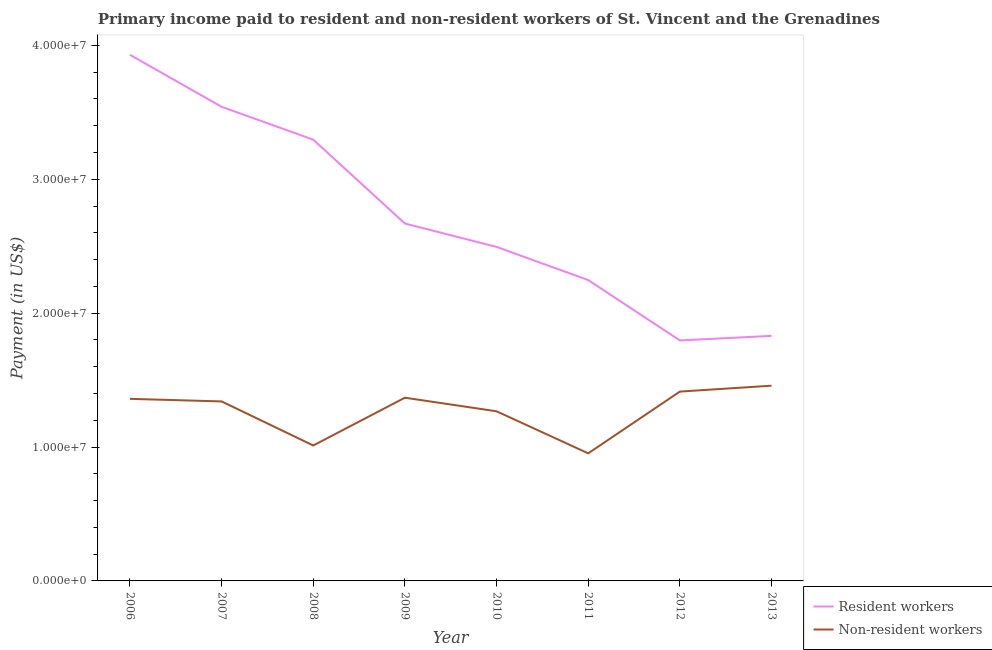What is the payment made to non-resident workers in 2013?
Offer a terse response. 1.46e+07. Across all years, what is the maximum payment made to non-resident workers?
Provide a succinct answer. 1.46e+07. Across all years, what is the minimum payment made to non-resident workers?
Ensure brevity in your answer.  9.53e+06. In which year was the payment made to non-resident workers maximum?
Give a very brief answer. 2013. What is the total payment made to resident workers in the graph?
Make the answer very short. 2.18e+08. What is the difference between the payment made to resident workers in 2007 and that in 2011?
Provide a short and direct response. 1.29e+07. What is the difference between the payment made to resident workers in 2010 and the payment made to non-resident workers in 2011?
Provide a succinct answer. 1.54e+07. What is the average payment made to non-resident workers per year?
Offer a terse response. 1.27e+07. In the year 2008, what is the difference between the payment made to non-resident workers and payment made to resident workers?
Make the answer very short. -2.28e+07. In how many years, is the payment made to resident workers greater than 38000000 US$?
Offer a very short reply. 1. What is the ratio of the payment made to resident workers in 2006 to that in 2009?
Ensure brevity in your answer.  1.47. Is the difference between the payment made to non-resident workers in 2008 and 2009 greater than the difference between the payment made to resident workers in 2008 and 2009?
Provide a short and direct response. No. What is the difference between the highest and the second highest payment made to resident workers?
Ensure brevity in your answer.  3.88e+06. What is the difference between the highest and the lowest payment made to resident workers?
Your answer should be very brief. 2.13e+07. In how many years, is the payment made to non-resident workers greater than the average payment made to non-resident workers taken over all years?
Your answer should be very brief. 5. Does the payment made to non-resident workers monotonically increase over the years?
Provide a short and direct response. No. Is the payment made to non-resident workers strictly greater than the payment made to resident workers over the years?
Keep it short and to the point. No. How many lines are there?
Your response must be concise. 2. What is the difference between two consecutive major ticks on the Y-axis?
Give a very brief answer. 1.00e+07. Are the values on the major ticks of Y-axis written in scientific E-notation?
Your response must be concise. Yes. Does the graph contain any zero values?
Ensure brevity in your answer.  No. Does the graph contain grids?
Make the answer very short. No. Where does the legend appear in the graph?
Your response must be concise. Bottom right. How many legend labels are there?
Ensure brevity in your answer.  2. How are the legend labels stacked?
Offer a terse response. Vertical. What is the title of the graph?
Give a very brief answer. Primary income paid to resident and non-resident workers of St. Vincent and the Grenadines. Does "Urban" appear as one of the legend labels in the graph?
Ensure brevity in your answer.  No. What is the label or title of the X-axis?
Offer a very short reply. Year. What is the label or title of the Y-axis?
Your answer should be very brief. Payment (in US$). What is the Payment (in US$) in Resident workers in 2006?
Provide a succinct answer. 3.93e+07. What is the Payment (in US$) in Non-resident workers in 2006?
Your answer should be compact. 1.36e+07. What is the Payment (in US$) of Resident workers in 2007?
Give a very brief answer. 3.54e+07. What is the Payment (in US$) of Non-resident workers in 2007?
Your response must be concise. 1.34e+07. What is the Payment (in US$) in Resident workers in 2008?
Your response must be concise. 3.30e+07. What is the Payment (in US$) in Non-resident workers in 2008?
Your response must be concise. 1.01e+07. What is the Payment (in US$) of Resident workers in 2009?
Your response must be concise. 2.67e+07. What is the Payment (in US$) in Non-resident workers in 2009?
Keep it short and to the point. 1.37e+07. What is the Payment (in US$) of Resident workers in 2010?
Make the answer very short. 2.49e+07. What is the Payment (in US$) of Non-resident workers in 2010?
Provide a succinct answer. 1.27e+07. What is the Payment (in US$) of Resident workers in 2011?
Provide a short and direct response. 2.25e+07. What is the Payment (in US$) in Non-resident workers in 2011?
Your answer should be compact. 9.53e+06. What is the Payment (in US$) of Resident workers in 2012?
Ensure brevity in your answer.  1.80e+07. What is the Payment (in US$) in Non-resident workers in 2012?
Make the answer very short. 1.41e+07. What is the Payment (in US$) in Resident workers in 2013?
Offer a very short reply. 1.83e+07. What is the Payment (in US$) of Non-resident workers in 2013?
Offer a very short reply. 1.46e+07. Across all years, what is the maximum Payment (in US$) of Resident workers?
Offer a terse response. 3.93e+07. Across all years, what is the maximum Payment (in US$) of Non-resident workers?
Make the answer very short. 1.46e+07. Across all years, what is the minimum Payment (in US$) of Resident workers?
Your answer should be very brief. 1.80e+07. Across all years, what is the minimum Payment (in US$) of Non-resident workers?
Your answer should be very brief. 9.53e+06. What is the total Payment (in US$) in Resident workers in the graph?
Your answer should be compact. 2.18e+08. What is the total Payment (in US$) in Non-resident workers in the graph?
Ensure brevity in your answer.  1.02e+08. What is the difference between the Payment (in US$) in Resident workers in 2006 and that in 2007?
Make the answer very short. 3.88e+06. What is the difference between the Payment (in US$) of Non-resident workers in 2006 and that in 2007?
Offer a terse response. 1.92e+05. What is the difference between the Payment (in US$) of Resident workers in 2006 and that in 2008?
Your answer should be compact. 6.34e+06. What is the difference between the Payment (in US$) of Non-resident workers in 2006 and that in 2008?
Offer a very short reply. 3.48e+06. What is the difference between the Payment (in US$) of Resident workers in 2006 and that in 2009?
Offer a terse response. 1.26e+07. What is the difference between the Payment (in US$) in Non-resident workers in 2006 and that in 2009?
Your answer should be very brief. -8.47e+04. What is the difference between the Payment (in US$) of Resident workers in 2006 and that in 2010?
Your response must be concise. 1.43e+07. What is the difference between the Payment (in US$) of Non-resident workers in 2006 and that in 2010?
Provide a succinct answer. 9.29e+05. What is the difference between the Payment (in US$) of Resident workers in 2006 and that in 2011?
Offer a terse response. 1.68e+07. What is the difference between the Payment (in US$) of Non-resident workers in 2006 and that in 2011?
Make the answer very short. 4.07e+06. What is the difference between the Payment (in US$) in Resident workers in 2006 and that in 2012?
Make the answer very short. 2.13e+07. What is the difference between the Payment (in US$) in Non-resident workers in 2006 and that in 2012?
Give a very brief answer. -5.43e+05. What is the difference between the Payment (in US$) in Resident workers in 2006 and that in 2013?
Provide a succinct answer. 2.10e+07. What is the difference between the Payment (in US$) in Non-resident workers in 2006 and that in 2013?
Make the answer very short. -9.82e+05. What is the difference between the Payment (in US$) of Resident workers in 2007 and that in 2008?
Your answer should be compact. 2.46e+06. What is the difference between the Payment (in US$) of Non-resident workers in 2007 and that in 2008?
Offer a very short reply. 3.29e+06. What is the difference between the Payment (in US$) in Resident workers in 2007 and that in 2009?
Ensure brevity in your answer.  8.72e+06. What is the difference between the Payment (in US$) of Non-resident workers in 2007 and that in 2009?
Provide a short and direct response. -2.77e+05. What is the difference between the Payment (in US$) in Resident workers in 2007 and that in 2010?
Your response must be concise. 1.05e+07. What is the difference between the Payment (in US$) of Non-resident workers in 2007 and that in 2010?
Give a very brief answer. 7.36e+05. What is the difference between the Payment (in US$) in Resident workers in 2007 and that in 2011?
Provide a succinct answer. 1.29e+07. What is the difference between the Payment (in US$) of Non-resident workers in 2007 and that in 2011?
Your response must be concise. 3.88e+06. What is the difference between the Payment (in US$) of Resident workers in 2007 and that in 2012?
Your answer should be very brief. 1.75e+07. What is the difference between the Payment (in US$) of Non-resident workers in 2007 and that in 2012?
Keep it short and to the point. -7.35e+05. What is the difference between the Payment (in US$) in Resident workers in 2007 and that in 2013?
Provide a succinct answer. 1.71e+07. What is the difference between the Payment (in US$) of Non-resident workers in 2007 and that in 2013?
Keep it short and to the point. -1.17e+06. What is the difference between the Payment (in US$) of Resident workers in 2008 and that in 2009?
Provide a succinct answer. 6.26e+06. What is the difference between the Payment (in US$) in Non-resident workers in 2008 and that in 2009?
Provide a succinct answer. -3.57e+06. What is the difference between the Payment (in US$) in Resident workers in 2008 and that in 2010?
Your answer should be compact. 8.01e+06. What is the difference between the Payment (in US$) of Non-resident workers in 2008 and that in 2010?
Your answer should be very brief. -2.55e+06. What is the difference between the Payment (in US$) of Resident workers in 2008 and that in 2011?
Provide a short and direct response. 1.05e+07. What is the difference between the Payment (in US$) in Non-resident workers in 2008 and that in 2011?
Keep it short and to the point. 5.87e+05. What is the difference between the Payment (in US$) of Resident workers in 2008 and that in 2012?
Offer a very short reply. 1.50e+07. What is the difference between the Payment (in US$) in Non-resident workers in 2008 and that in 2012?
Your answer should be compact. -4.03e+06. What is the difference between the Payment (in US$) in Resident workers in 2008 and that in 2013?
Offer a terse response. 1.47e+07. What is the difference between the Payment (in US$) of Non-resident workers in 2008 and that in 2013?
Ensure brevity in your answer.  -4.47e+06. What is the difference between the Payment (in US$) in Resident workers in 2009 and that in 2010?
Make the answer very short. 1.75e+06. What is the difference between the Payment (in US$) in Non-resident workers in 2009 and that in 2010?
Offer a very short reply. 1.01e+06. What is the difference between the Payment (in US$) in Resident workers in 2009 and that in 2011?
Your response must be concise. 4.22e+06. What is the difference between the Payment (in US$) of Non-resident workers in 2009 and that in 2011?
Your answer should be compact. 4.16e+06. What is the difference between the Payment (in US$) of Resident workers in 2009 and that in 2012?
Give a very brief answer. 8.73e+06. What is the difference between the Payment (in US$) in Non-resident workers in 2009 and that in 2012?
Your answer should be very brief. -4.58e+05. What is the difference between the Payment (in US$) in Resident workers in 2009 and that in 2013?
Ensure brevity in your answer.  8.39e+06. What is the difference between the Payment (in US$) of Non-resident workers in 2009 and that in 2013?
Offer a very short reply. -8.98e+05. What is the difference between the Payment (in US$) of Resident workers in 2010 and that in 2011?
Offer a terse response. 2.48e+06. What is the difference between the Payment (in US$) of Non-resident workers in 2010 and that in 2011?
Ensure brevity in your answer.  3.14e+06. What is the difference between the Payment (in US$) in Resident workers in 2010 and that in 2012?
Offer a very short reply. 6.99e+06. What is the difference between the Payment (in US$) of Non-resident workers in 2010 and that in 2012?
Your answer should be compact. -1.47e+06. What is the difference between the Payment (in US$) in Resident workers in 2010 and that in 2013?
Ensure brevity in your answer.  6.65e+06. What is the difference between the Payment (in US$) in Non-resident workers in 2010 and that in 2013?
Your answer should be very brief. -1.91e+06. What is the difference between the Payment (in US$) of Resident workers in 2011 and that in 2012?
Give a very brief answer. 4.51e+06. What is the difference between the Payment (in US$) of Non-resident workers in 2011 and that in 2012?
Make the answer very short. -4.61e+06. What is the difference between the Payment (in US$) of Resident workers in 2011 and that in 2013?
Your response must be concise. 4.17e+06. What is the difference between the Payment (in US$) in Non-resident workers in 2011 and that in 2013?
Offer a very short reply. -5.05e+06. What is the difference between the Payment (in US$) in Resident workers in 2012 and that in 2013?
Your answer should be very brief. -3.41e+05. What is the difference between the Payment (in US$) in Non-resident workers in 2012 and that in 2013?
Your response must be concise. -4.39e+05. What is the difference between the Payment (in US$) in Resident workers in 2006 and the Payment (in US$) in Non-resident workers in 2007?
Offer a very short reply. 2.59e+07. What is the difference between the Payment (in US$) in Resident workers in 2006 and the Payment (in US$) in Non-resident workers in 2008?
Your answer should be very brief. 2.92e+07. What is the difference between the Payment (in US$) in Resident workers in 2006 and the Payment (in US$) in Non-resident workers in 2009?
Offer a very short reply. 2.56e+07. What is the difference between the Payment (in US$) of Resident workers in 2006 and the Payment (in US$) of Non-resident workers in 2010?
Your response must be concise. 2.66e+07. What is the difference between the Payment (in US$) in Resident workers in 2006 and the Payment (in US$) in Non-resident workers in 2011?
Offer a very short reply. 2.98e+07. What is the difference between the Payment (in US$) of Resident workers in 2006 and the Payment (in US$) of Non-resident workers in 2012?
Offer a very short reply. 2.52e+07. What is the difference between the Payment (in US$) of Resident workers in 2006 and the Payment (in US$) of Non-resident workers in 2013?
Give a very brief answer. 2.47e+07. What is the difference between the Payment (in US$) in Resident workers in 2007 and the Payment (in US$) in Non-resident workers in 2008?
Your answer should be very brief. 2.53e+07. What is the difference between the Payment (in US$) of Resident workers in 2007 and the Payment (in US$) of Non-resident workers in 2009?
Offer a terse response. 2.17e+07. What is the difference between the Payment (in US$) of Resident workers in 2007 and the Payment (in US$) of Non-resident workers in 2010?
Your response must be concise. 2.27e+07. What is the difference between the Payment (in US$) in Resident workers in 2007 and the Payment (in US$) in Non-resident workers in 2011?
Provide a short and direct response. 2.59e+07. What is the difference between the Payment (in US$) of Resident workers in 2007 and the Payment (in US$) of Non-resident workers in 2012?
Keep it short and to the point. 2.13e+07. What is the difference between the Payment (in US$) of Resident workers in 2007 and the Payment (in US$) of Non-resident workers in 2013?
Offer a terse response. 2.08e+07. What is the difference between the Payment (in US$) in Resident workers in 2008 and the Payment (in US$) in Non-resident workers in 2009?
Provide a succinct answer. 1.93e+07. What is the difference between the Payment (in US$) of Resident workers in 2008 and the Payment (in US$) of Non-resident workers in 2010?
Your answer should be very brief. 2.03e+07. What is the difference between the Payment (in US$) of Resident workers in 2008 and the Payment (in US$) of Non-resident workers in 2011?
Provide a succinct answer. 2.34e+07. What is the difference between the Payment (in US$) in Resident workers in 2008 and the Payment (in US$) in Non-resident workers in 2012?
Offer a terse response. 1.88e+07. What is the difference between the Payment (in US$) of Resident workers in 2008 and the Payment (in US$) of Non-resident workers in 2013?
Ensure brevity in your answer.  1.84e+07. What is the difference between the Payment (in US$) of Resident workers in 2009 and the Payment (in US$) of Non-resident workers in 2010?
Keep it short and to the point. 1.40e+07. What is the difference between the Payment (in US$) in Resident workers in 2009 and the Payment (in US$) in Non-resident workers in 2011?
Provide a short and direct response. 1.72e+07. What is the difference between the Payment (in US$) in Resident workers in 2009 and the Payment (in US$) in Non-resident workers in 2012?
Provide a succinct answer. 1.26e+07. What is the difference between the Payment (in US$) of Resident workers in 2009 and the Payment (in US$) of Non-resident workers in 2013?
Ensure brevity in your answer.  1.21e+07. What is the difference between the Payment (in US$) in Resident workers in 2010 and the Payment (in US$) in Non-resident workers in 2011?
Provide a succinct answer. 1.54e+07. What is the difference between the Payment (in US$) in Resident workers in 2010 and the Payment (in US$) in Non-resident workers in 2012?
Offer a terse response. 1.08e+07. What is the difference between the Payment (in US$) of Resident workers in 2010 and the Payment (in US$) of Non-resident workers in 2013?
Your answer should be compact. 1.04e+07. What is the difference between the Payment (in US$) in Resident workers in 2011 and the Payment (in US$) in Non-resident workers in 2012?
Your answer should be very brief. 8.33e+06. What is the difference between the Payment (in US$) of Resident workers in 2011 and the Payment (in US$) of Non-resident workers in 2013?
Give a very brief answer. 7.89e+06. What is the difference between the Payment (in US$) in Resident workers in 2012 and the Payment (in US$) in Non-resident workers in 2013?
Give a very brief answer. 3.38e+06. What is the average Payment (in US$) of Resident workers per year?
Offer a terse response. 2.73e+07. What is the average Payment (in US$) of Non-resident workers per year?
Your response must be concise. 1.27e+07. In the year 2006, what is the difference between the Payment (in US$) of Resident workers and Payment (in US$) of Non-resident workers?
Keep it short and to the point. 2.57e+07. In the year 2007, what is the difference between the Payment (in US$) of Resident workers and Payment (in US$) of Non-resident workers?
Provide a short and direct response. 2.20e+07. In the year 2008, what is the difference between the Payment (in US$) in Resident workers and Payment (in US$) in Non-resident workers?
Ensure brevity in your answer.  2.28e+07. In the year 2009, what is the difference between the Payment (in US$) in Resident workers and Payment (in US$) in Non-resident workers?
Give a very brief answer. 1.30e+07. In the year 2010, what is the difference between the Payment (in US$) in Resident workers and Payment (in US$) in Non-resident workers?
Provide a short and direct response. 1.23e+07. In the year 2011, what is the difference between the Payment (in US$) in Resident workers and Payment (in US$) in Non-resident workers?
Provide a succinct answer. 1.29e+07. In the year 2012, what is the difference between the Payment (in US$) of Resident workers and Payment (in US$) of Non-resident workers?
Your response must be concise. 3.82e+06. In the year 2013, what is the difference between the Payment (in US$) of Resident workers and Payment (in US$) of Non-resident workers?
Make the answer very short. 3.72e+06. What is the ratio of the Payment (in US$) in Resident workers in 2006 to that in 2007?
Provide a short and direct response. 1.11. What is the ratio of the Payment (in US$) in Non-resident workers in 2006 to that in 2007?
Keep it short and to the point. 1.01. What is the ratio of the Payment (in US$) of Resident workers in 2006 to that in 2008?
Keep it short and to the point. 1.19. What is the ratio of the Payment (in US$) of Non-resident workers in 2006 to that in 2008?
Your answer should be compact. 1.34. What is the ratio of the Payment (in US$) of Resident workers in 2006 to that in 2009?
Your answer should be compact. 1.47. What is the ratio of the Payment (in US$) in Resident workers in 2006 to that in 2010?
Offer a very short reply. 1.58. What is the ratio of the Payment (in US$) in Non-resident workers in 2006 to that in 2010?
Offer a very short reply. 1.07. What is the ratio of the Payment (in US$) of Resident workers in 2006 to that in 2011?
Give a very brief answer. 1.75. What is the ratio of the Payment (in US$) of Non-resident workers in 2006 to that in 2011?
Ensure brevity in your answer.  1.43. What is the ratio of the Payment (in US$) of Resident workers in 2006 to that in 2012?
Your answer should be compact. 2.19. What is the ratio of the Payment (in US$) of Non-resident workers in 2006 to that in 2012?
Make the answer very short. 0.96. What is the ratio of the Payment (in US$) in Resident workers in 2006 to that in 2013?
Provide a succinct answer. 2.15. What is the ratio of the Payment (in US$) of Non-resident workers in 2006 to that in 2013?
Make the answer very short. 0.93. What is the ratio of the Payment (in US$) in Resident workers in 2007 to that in 2008?
Ensure brevity in your answer.  1.07. What is the ratio of the Payment (in US$) of Non-resident workers in 2007 to that in 2008?
Your response must be concise. 1.33. What is the ratio of the Payment (in US$) in Resident workers in 2007 to that in 2009?
Provide a succinct answer. 1.33. What is the ratio of the Payment (in US$) of Non-resident workers in 2007 to that in 2009?
Keep it short and to the point. 0.98. What is the ratio of the Payment (in US$) in Resident workers in 2007 to that in 2010?
Your answer should be compact. 1.42. What is the ratio of the Payment (in US$) in Non-resident workers in 2007 to that in 2010?
Provide a succinct answer. 1.06. What is the ratio of the Payment (in US$) in Resident workers in 2007 to that in 2011?
Give a very brief answer. 1.58. What is the ratio of the Payment (in US$) of Non-resident workers in 2007 to that in 2011?
Offer a terse response. 1.41. What is the ratio of the Payment (in US$) in Resident workers in 2007 to that in 2012?
Your answer should be compact. 1.97. What is the ratio of the Payment (in US$) of Non-resident workers in 2007 to that in 2012?
Your response must be concise. 0.95. What is the ratio of the Payment (in US$) of Resident workers in 2007 to that in 2013?
Provide a short and direct response. 1.93. What is the ratio of the Payment (in US$) of Non-resident workers in 2007 to that in 2013?
Offer a very short reply. 0.92. What is the ratio of the Payment (in US$) of Resident workers in 2008 to that in 2009?
Your response must be concise. 1.23. What is the ratio of the Payment (in US$) in Non-resident workers in 2008 to that in 2009?
Offer a very short reply. 0.74. What is the ratio of the Payment (in US$) of Resident workers in 2008 to that in 2010?
Give a very brief answer. 1.32. What is the ratio of the Payment (in US$) in Non-resident workers in 2008 to that in 2010?
Offer a very short reply. 0.8. What is the ratio of the Payment (in US$) in Resident workers in 2008 to that in 2011?
Your answer should be compact. 1.47. What is the ratio of the Payment (in US$) in Non-resident workers in 2008 to that in 2011?
Offer a terse response. 1.06. What is the ratio of the Payment (in US$) of Resident workers in 2008 to that in 2012?
Give a very brief answer. 1.83. What is the ratio of the Payment (in US$) of Non-resident workers in 2008 to that in 2012?
Offer a terse response. 0.72. What is the ratio of the Payment (in US$) of Resident workers in 2008 to that in 2013?
Offer a very short reply. 1.8. What is the ratio of the Payment (in US$) in Non-resident workers in 2008 to that in 2013?
Offer a terse response. 0.69. What is the ratio of the Payment (in US$) in Resident workers in 2009 to that in 2010?
Your response must be concise. 1.07. What is the ratio of the Payment (in US$) of Non-resident workers in 2009 to that in 2010?
Your answer should be very brief. 1.08. What is the ratio of the Payment (in US$) in Resident workers in 2009 to that in 2011?
Your response must be concise. 1.19. What is the ratio of the Payment (in US$) of Non-resident workers in 2009 to that in 2011?
Ensure brevity in your answer.  1.44. What is the ratio of the Payment (in US$) in Resident workers in 2009 to that in 2012?
Provide a succinct answer. 1.49. What is the ratio of the Payment (in US$) in Non-resident workers in 2009 to that in 2012?
Your answer should be very brief. 0.97. What is the ratio of the Payment (in US$) of Resident workers in 2009 to that in 2013?
Offer a terse response. 1.46. What is the ratio of the Payment (in US$) of Non-resident workers in 2009 to that in 2013?
Your answer should be compact. 0.94. What is the ratio of the Payment (in US$) in Resident workers in 2010 to that in 2011?
Ensure brevity in your answer.  1.11. What is the ratio of the Payment (in US$) of Non-resident workers in 2010 to that in 2011?
Make the answer very short. 1.33. What is the ratio of the Payment (in US$) in Resident workers in 2010 to that in 2012?
Your answer should be compact. 1.39. What is the ratio of the Payment (in US$) in Non-resident workers in 2010 to that in 2012?
Make the answer very short. 0.9. What is the ratio of the Payment (in US$) of Resident workers in 2010 to that in 2013?
Your answer should be compact. 1.36. What is the ratio of the Payment (in US$) of Non-resident workers in 2010 to that in 2013?
Make the answer very short. 0.87. What is the ratio of the Payment (in US$) of Resident workers in 2011 to that in 2012?
Keep it short and to the point. 1.25. What is the ratio of the Payment (in US$) in Non-resident workers in 2011 to that in 2012?
Offer a very short reply. 0.67. What is the ratio of the Payment (in US$) in Resident workers in 2011 to that in 2013?
Offer a very short reply. 1.23. What is the ratio of the Payment (in US$) in Non-resident workers in 2011 to that in 2013?
Offer a very short reply. 0.65. What is the ratio of the Payment (in US$) of Resident workers in 2012 to that in 2013?
Offer a very short reply. 0.98. What is the ratio of the Payment (in US$) in Non-resident workers in 2012 to that in 2013?
Your answer should be compact. 0.97. What is the difference between the highest and the second highest Payment (in US$) in Resident workers?
Provide a short and direct response. 3.88e+06. What is the difference between the highest and the second highest Payment (in US$) of Non-resident workers?
Ensure brevity in your answer.  4.39e+05. What is the difference between the highest and the lowest Payment (in US$) of Resident workers?
Offer a terse response. 2.13e+07. What is the difference between the highest and the lowest Payment (in US$) of Non-resident workers?
Provide a short and direct response. 5.05e+06. 